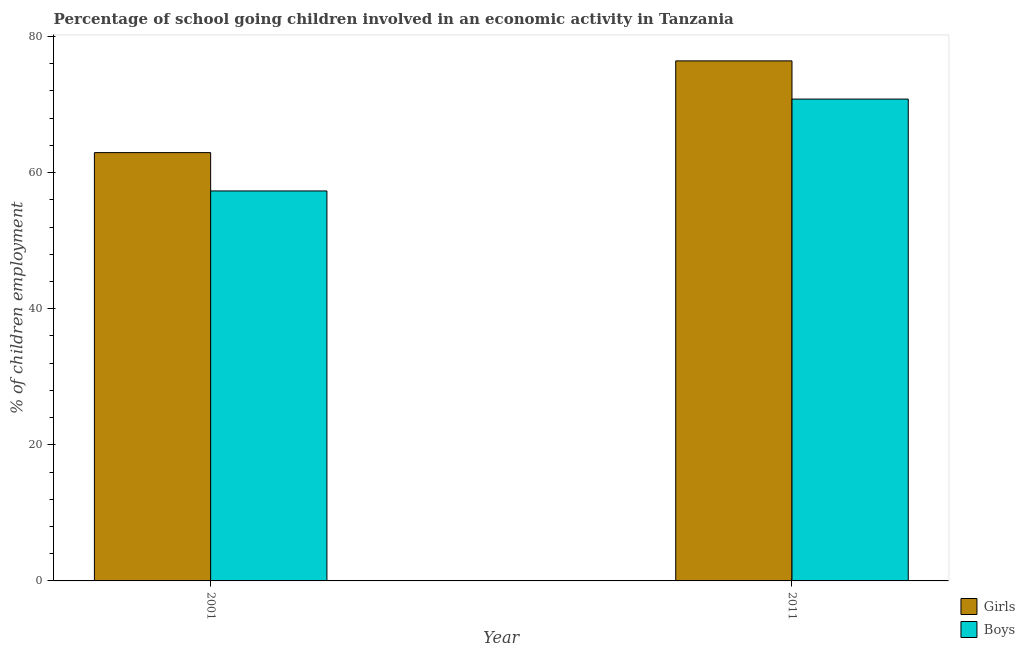How many different coloured bars are there?
Offer a terse response. 2. How many groups of bars are there?
Offer a terse response. 2. Are the number of bars per tick equal to the number of legend labels?
Your response must be concise. Yes. Are the number of bars on each tick of the X-axis equal?
Offer a terse response. Yes. In how many cases, is the number of bars for a given year not equal to the number of legend labels?
Your answer should be compact. 0. What is the percentage of school going girls in 2011?
Provide a short and direct response. 76.41. Across all years, what is the maximum percentage of school going boys?
Your answer should be very brief. 70.8. Across all years, what is the minimum percentage of school going girls?
Offer a terse response. 62.93. What is the total percentage of school going girls in the graph?
Make the answer very short. 139.35. What is the difference between the percentage of school going boys in 2001 and that in 2011?
Provide a succinct answer. -13.5. What is the difference between the percentage of school going boys in 2011 and the percentage of school going girls in 2001?
Keep it short and to the point. 13.5. What is the average percentage of school going girls per year?
Give a very brief answer. 69.67. In how many years, is the percentage of school going boys greater than 76 %?
Your response must be concise. 0. What is the ratio of the percentage of school going girls in 2001 to that in 2011?
Ensure brevity in your answer.  0.82. Is the percentage of school going boys in 2001 less than that in 2011?
Offer a terse response. Yes. In how many years, is the percentage of school going girls greater than the average percentage of school going girls taken over all years?
Give a very brief answer. 1. What does the 1st bar from the left in 2001 represents?
Make the answer very short. Girls. What does the 1st bar from the right in 2001 represents?
Make the answer very short. Boys. Are all the bars in the graph horizontal?
Keep it short and to the point. No. What is the difference between two consecutive major ticks on the Y-axis?
Your answer should be compact. 20. Does the graph contain grids?
Your response must be concise. No. Where does the legend appear in the graph?
Provide a short and direct response. Bottom right. How are the legend labels stacked?
Offer a terse response. Vertical. What is the title of the graph?
Your answer should be compact. Percentage of school going children involved in an economic activity in Tanzania. Does "From production" appear as one of the legend labels in the graph?
Offer a terse response. No. What is the label or title of the Y-axis?
Your response must be concise. % of children employment. What is the % of children employment in Girls in 2001?
Ensure brevity in your answer.  62.93. What is the % of children employment of Boys in 2001?
Your answer should be very brief. 57.3. What is the % of children employment of Girls in 2011?
Offer a terse response. 76.41. What is the % of children employment of Boys in 2011?
Your answer should be compact. 70.8. Across all years, what is the maximum % of children employment in Girls?
Your answer should be compact. 76.41. Across all years, what is the maximum % of children employment of Boys?
Offer a very short reply. 70.8. Across all years, what is the minimum % of children employment in Girls?
Your answer should be very brief. 62.93. Across all years, what is the minimum % of children employment of Boys?
Provide a succinct answer. 57.3. What is the total % of children employment in Girls in the graph?
Your answer should be compact. 139.35. What is the total % of children employment of Boys in the graph?
Your answer should be compact. 128.1. What is the difference between the % of children employment of Girls in 2001 and that in 2011?
Your answer should be compact. -13.48. What is the difference between the % of children employment in Boys in 2001 and that in 2011?
Make the answer very short. -13.5. What is the difference between the % of children employment in Girls in 2001 and the % of children employment in Boys in 2011?
Your answer should be compact. -7.87. What is the average % of children employment of Girls per year?
Offer a very short reply. 69.67. What is the average % of children employment in Boys per year?
Your response must be concise. 64.05. In the year 2001, what is the difference between the % of children employment of Girls and % of children employment of Boys?
Your response must be concise. 5.63. In the year 2011, what is the difference between the % of children employment of Girls and % of children employment of Boys?
Offer a very short reply. 5.61. What is the ratio of the % of children employment in Girls in 2001 to that in 2011?
Provide a short and direct response. 0.82. What is the ratio of the % of children employment of Boys in 2001 to that in 2011?
Your response must be concise. 0.81. What is the difference between the highest and the second highest % of children employment of Girls?
Your answer should be very brief. 13.48. What is the difference between the highest and the second highest % of children employment in Boys?
Provide a short and direct response. 13.5. What is the difference between the highest and the lowest % of children employment of Girls?
Offer a very short reply. 13.48. What is the difference between the highest and the lowest % of children employment of Boys?
Provide a succinct answer. 13.5. 